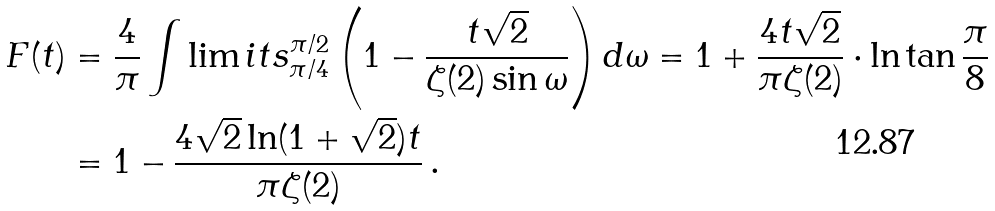<formula> <loc_0><loc_0><loc_500><loc_500>F ( t ) & = \frac { 4 } { \pi } \int \lim i t s _ { \pi / 4 } ^ { \pi / 2 } \left ( 1 - \frac { t \sqrt { 2 } } { \zeta ( 2 ) \sin \omega } \right ) d \omega = 1 + \frac { 4 t \sqrt { 2 } } { \pi \zeta ( 2 ) } \cdot \ln \tan \frac { \pi } { 8 } \\ & = 1 - \frac { 4 \sqrt { 2 } \ln ( 1 + \sqrt { 2 } ) t } { \pi \zeta ( 2 ) } \, .</formula> 